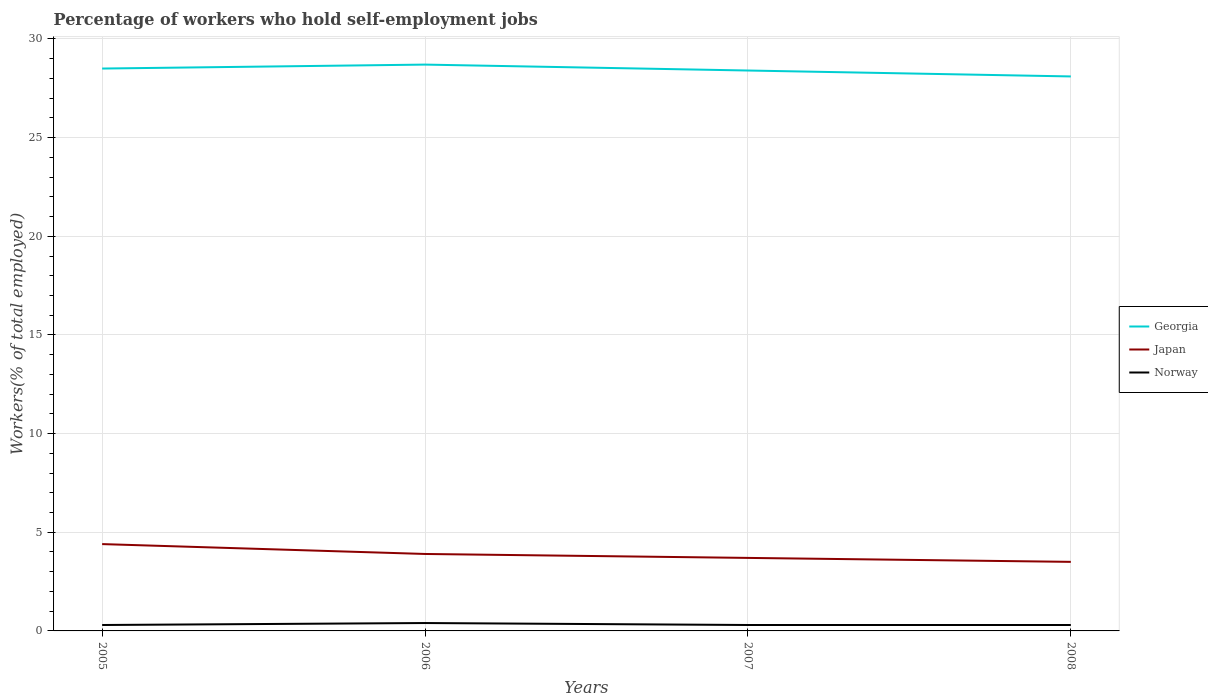Does the line corresponding to Norway intersect with the line corresponding to Georgia?
Ensure brevity in your answer.  No. In which year was the percentage of self-employed workers in Japan maximum?
Your response must be concise. 2008. What is the total percentage of self-employed workers in Japan in the graph?
Offer a terse response. 0.2. What is the difference between the highest and the second highest percentage of self-employed workers in Japan?
Give a very brief answer. 0.9. Is the percentage of self-employed workers in Japan strictly greater than the percentage of self-employed workers in Norway over the years?
Keep it short and to the point. No. What is the difference between two consecutive major ticks on the Y-axis?
Make the answer very short. 5. Are the values on the major ticks of Y-axis written in scientific E-notation?
Keep it short and to the point. No. Does the graph contain any zero values?
Your answer should be very brief. No. Does the graph contain grids?
Give a very brief answer. Yes. Where does the legend appear in the graph?
Ensure brevity in your answer.  Center right. How are the legend labels stacked?
Provide a short and direct response. Vertical. What is the title of the graph?
Your answer should be very brief. Percentage of workers who hold self-employment jobs. Does "High income: OECD" appear as one of the legend labels in the graph?
Make the answer very short. No. What is the label or title of the X-axis?
Offer a terse response. Years. What is the label or title of the Y-axis?
Provide a succinct answer. Workers(% of total employed). What is the Workers(% of total employed) in Georgia in 2005?
Keep it short and to the point. 28.5. What is the Workers(% of total employed) in Japan in 2005?
Give a very brief answer. 4.4. What is the Workers(% of total employed) of Norway in 2005?
Ensure brevity in your answer.  0.3. What is the Workers(% of total employed) of Georgia in 2006?
Provide a short and direct response. 28.7. What is the Workers(% of total employed) of Japan in 2006?
Offer a terse response. 3.9. What is the Workers(% of total employed) of Norway in 2006?
Your response must be concise. 0.4. What is the Workers(% of total employed) in Georgia in 2007?
Your answer should be very brief. 28.4. What is the Workers(% of total employed) in Japan in 2007?
Offer a terse response. 3.7. What is the Workers(% of total employed) in Norway in 2007?
Provide a short and direct response. 0.3. What is the Workers(% of total employed) of Georgia in 2008?
Keep it short and to the point. 28.1. What is the Workers(% of total employed) in Japan in 2008?
Offer a very short reply. 3.5. What is the Workers(% of total employed) of Norway in 2008?
Your answer should be very brief. 0.3. Across all years, what is the maximum Workers(% of total employed) of Georgia?
Your answer should be compact. 28.7. Across all years, what is the maximum Workers(% of total employed) of Japan?
Your response must be concise. 4.4. Across all years, what is the maximum Workers(% of total employed) in Norway?
Give a very brief answer. 0.4. Across all years, what is the minimum Workers(% of total employed) in Georgia?
Provide a succinct answer. 28.1. Across all years, what is the minimum Workers(% of total employed) of Norway?
Your answer should be compact. 0.3. What is the total Workers(% of total employed) in Georgia in the graph?
Provide a short and direct response. 113.7. What is the total Workers(% of total employed) of Japan in the graph?
Your answer should be very brief. 15.5. What is the total Workers(% of total employed) of Norway in the graph?
Your answer should be compact. 1.3. What is the difference between the Workers(% of total employed) in Georgia in 2005 and that in 2006?
Make the answer very short. -0.2. What is the difference between the Workers(% of total employed) in Japan in 2005 and that in 2006?
Give a very brief answer. 0.5. What is the difference between the Workers(% of total employed) of Norway in 2005 and that in 2006?
Offer a very short reply. -0.1. What is the difference between the Workers(% of total employed) in Georgia in 2005 and that in 2007?
Offer a terse response. 0.1. What is the difference between the Workers(% of total employed) of Japan in 2005 and that in 2007?
Provide a short and direct response. 0.7. What is the difference between the Workers(% of total employed) in Georgia in 2006 and that in 2007?
Provide a short and direct response. 0.3. What is the difference between the Workers(% of total employed) in Japan in 2006 and that in 2007?
Provide a short and direct response. 0.2. What is the difference between the Workers(% of total employed) in Georgia in 2006 and that in 2008?
Your answer should be compact. 0.6. What is the difference between the Workers(% of total employed) of Japan in 2006 and that in 2008?
Offer a terse response. 0.4. What is the difference between the Workers(% of total employed) of Norway in 2006 and that in 2008?
Your response must be concise. 0.1. What is the difference between the Workers(% of total employed) of Japan in 2007 and that in 2008?
Your answer should be very brief. 0.2. What is the difference between the Workers(% of total employed) in Georgia in 2005 and the Workers(% of total employed) in Japan in 2006?
Provide a short and direct response. 24.6. What is the difference between the Workers(% of total employed) of Georgia in 2005 and the Workers(% of total employed) of Norway in 2006?
Make the answer very short. 28.1. What is the difference between the Workers(% of total employed) in Georgia in 2005 and the Workers(% of total employed) in Japan in 2007?
Your response must be concise. 24.8. What is the difference between the Workers(% of total employed) of Georgia in 2005 and the Workers(% of total employed) of Norway in 2007?
Your response must be concise. 28.2. What is the difference between the Workers(% of total employed) in Japan in 2005 and the Workers(% of total employed) in Norway in 2007?
Your response must be concise. 4.1. What is the difference between the Workers(% of total employed) in Georgia in 2005 and the Workers(% of total employed) in Norway in 2008?
Provide a succinct answer. 28.2. What is the difference between the Workers(% of total employed) of Japan in 2005 and the Workers(% of total employed) of Norway in 2008?
Ensure brevity in your answer.  4.1. What is the difference between the Workers(% of total employed) in Georgia in 2006 and the Workers(% of total employed) in Norway in 2007?
Make the answer very short. 28.4. What is the difference between the Workers(% of total employed) in Georgia in 2006 and the Workers(% of total employed) in Japan in 2008?
Make the answer very short. 25.2. What is the difference between the Workers(% of total employed) in Georgia in 2006 and the Workers(% of total employed) in Norway in 2008?
Offer a terse response. 28.4. What is the difference between the Workers(% of total employed) in Japan in 2006 and the Workers(% of total employed) in Norway in 2008?
Offer a very short reply. 3.6. What is the difference between the Workers(% of total employed) in Georgia in 2007 and the Workers(% of total employed) in Japan in 2008?
Your answer should be compact. 24.9. What is the difference between the Workers(% of total employed) in Georgia in 2007 and the Workers(% of total employed) in Norway in 2008?
Give a very brief answer. 28.1. What is the average Workers(% of total employed) in Georgia per year?
Provide a short and direct response. 28.43. What is the average Workers(% of total employed) in Japan per year?
Offer a very short reply. 3.88. What is the average Workers(% of total employed) of Norway per year?
Your answer should be compact. 0.33. In the year 2005, what is the difference between the Workers(% of total employed) in Georgia and Workers(% of total employed) in Japan?
Provide a short and direct response. 24.1. In the year 2005, what is the difference between the Workers(% of total employed) of Georgia and Workers(% of total employed) of Norway?
Your response must be concise. 28.2. In the year 2006, what is the difference between the Workers(% of total employed) of Georgia and Workers(% of total employed) of Japan?
Ensure brevity in your answer.  24.8. In the year 2006, what is the difference between the Workers(% of total employed) of Georgia and Workers(% of total employed) of Norway?
Offer a terse response. 28.3. In the year 2006, what is the difference between the Workers(% of total employed) of Japan and Workers(% of total employed) of Norway?
Offer a terse response. 3.5. In the year 2007, what is the difference between the Workers(% of total employed) of Georgia and Workers(% of total employed) of Japan?
Give a very brief answer. 24.7. In the year 2007, what is the difference between the Workers(% of total employed) in Georgia and Workers(% of total employed) in Norway?
Offer a terse response. 28.1. In the year 2007, what is the difference between the Workers(% of total employed) of Japan and Workers(% of total employed) of Norway?
Keep it short and to the point. 3.4. In the year 2008, what is the difference between the Workers(% of total employed) in Georgia and Workers(% of total employed) in Japan?
Your answer should be compact. 24.6. In the year 2008, what is the difference between the Workers(% of total employed) in Georgia and Workers(% of total employed) in Norway?
Your answer should be very brief. 27.8. What is the ratio of the Workers(% of total employed) in Japan in 2005 to that in 2006?
Offer a very short reply. 1.13. What is the ratio of the Workers(% of total employed) of Georgia in 2005 to that in 2007?
Your answer should be compact. 1. What is the ratio of the Workers(% of total employed) of Japan in 2005 to that in 2007?
Your answer should be very brief. 1.19. What is the ratio of the Workers(% of total employed) in Norway in 2005 to that in 2007?
Provide a short and direct response. 1. What is the ratio of the Workers(% of total employed) in Georgia in 2005 to that in 2008?
Provide a short and direct response. 1.01. What is the ratio of the Workers(% of total employed) of Japan in 2005 to that in 2008?
Give a very brief answer. 1.26. What is the ratio of the Workers(% of total employed) in Georgia in 2006 to that in 2007?
Give a very brief answer. 1.01. What is the ratio of the Workers(% of total employed) of Japan in 2006 to that in 2007?
Make the answer very short. 1.05. What is the ratio of the Workers(% of total employed) in Norway in 2006 to that in 2007?
Your response must be concise. 1.33. What is the ratio of the Workers(% of total employed) of Georgia in 2006 to that in 2008?
Provide a short and direct response. 1.02. What is the ratio of the Workers(% of total employed) in Japan in 2006 to that in 2008?
Your answer should be compact. 1.11. What is the ratio of the Workers(% of total employed) of Norway in 2006 to that in 2008?
Give a very brief answer. 1.33. What is the ratio of the Workers(% of total employed) of Georgia in 2007 to that in 2008?
Keep it short and to the point. 1.01. What is the ratio of the Workers(% of total employed) of Japan in 2007 to that in 2008?
Your answer should be compact. 1.06. What is the ratio of the Workers(% of total employed) in Norway in 2007 to that in 2008?
Offer a terse response. 1. What is the difference between the highest and the second highest Workers(% of total employed) in Japan?
Keep it short and to the point. 0.5. What is the difference between the highest and the second highest Workers(% of total employed) in Norway?
Make the answer very short. 0.1. What is the difference between the highest and the lowest Workers(% of total employed) in Japan?
Your answer should be very brief. 0.9. What is the difference between the highest and the lowest Workers(% of total employed) of Norway?
Ensure brevity in your answer.  0.1. 